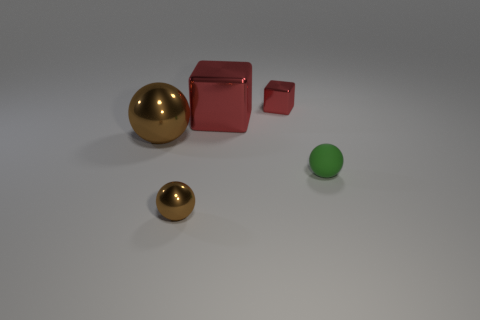Add 2 red objects. How many objects exist? 7 Subtract all spheres. How many objects are left? 2 Subtract all big blue metal cylinders. Subtract all large brown metal things. How many objects are left? 4 Add 4 small red metallic blocks. How many small red metallic blocks are left? 5 Add 4 small cubes. How many small cubes exist? 5 Subtract 0 blue balls. How many objects are left? 5 